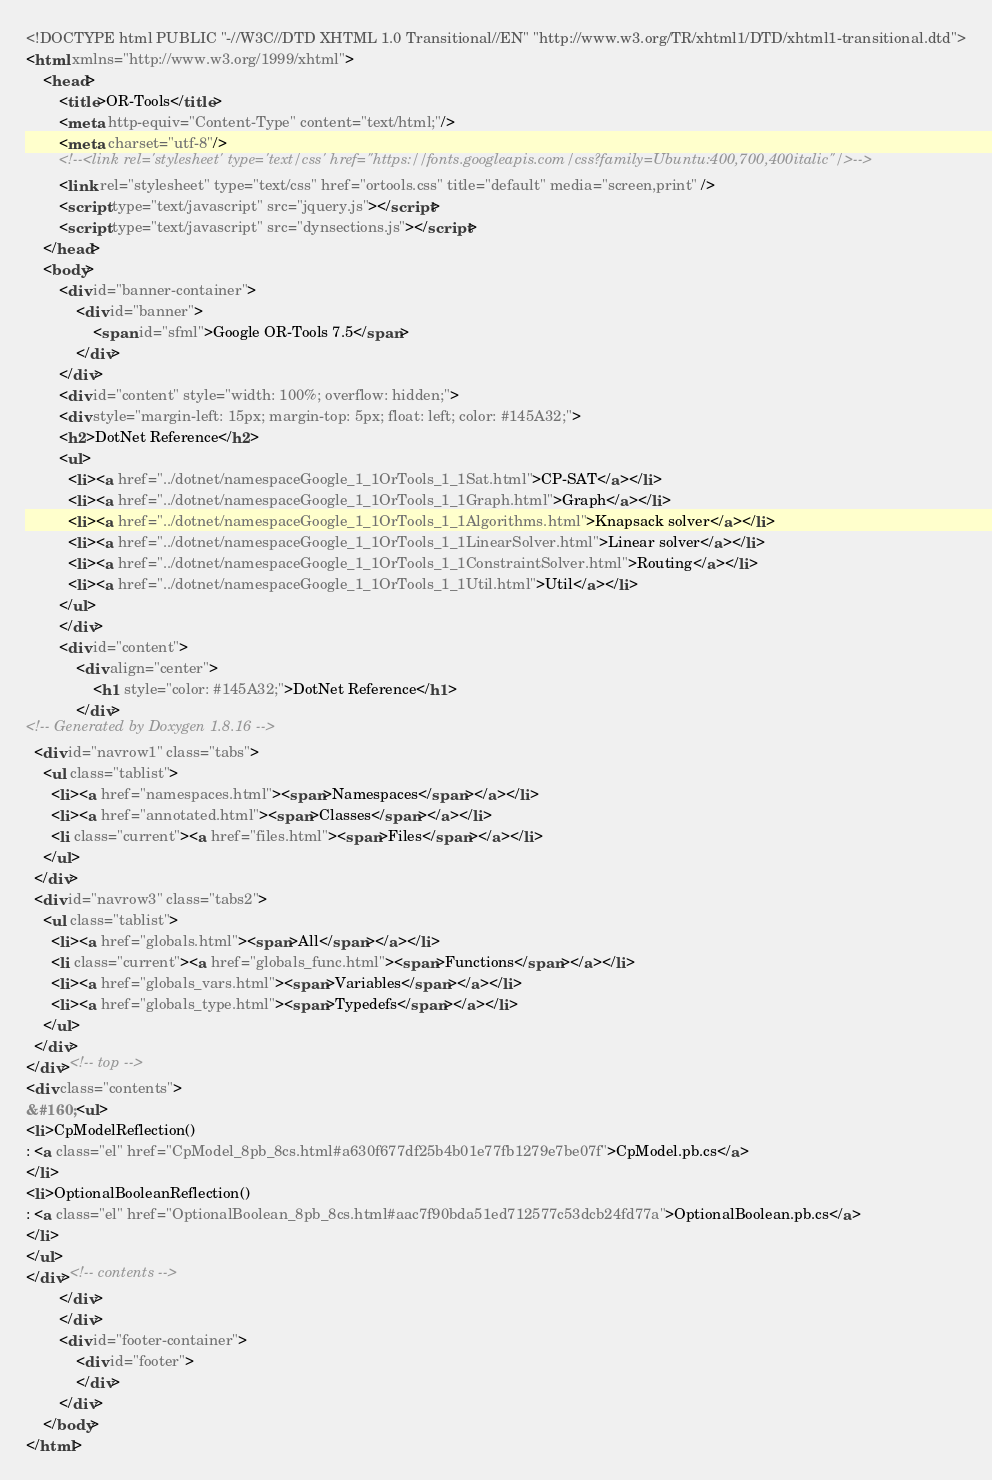Convert code to text. <code><loc_0><loc_0><loc_500><loc_500><_HTML_><!DOCTYPE html PUBLIC "-//W3C//DTD XHTML 1.0 Transitional//EN" "http://www.w3.org/TR/xhtml1/DTD/xhtml1-transitional.dtd">
<html xmlns="http://www.w3.org/1999/xhtml">
    <head>
        <title>OR-Tools</title>
        <meta http-equiv="Content-Type" content="text/html;"/>
        <meta charset="utf-8"/>
        <!--<link rel='stylesheet' type='text/css' href="https://fonts.googleapis.com/css?family=Ubuntu:400,700,400italic"/>-->
        <link rel="stylesheet" type="text/css" href="ortools.css" title="default" media="screen,print" />
        <script type="text/javascript" src="jquery.js"></script>
        <script type="text/javascript" src="dynsections.js"></script>
    </head>
    <body>
        <div id="banner-container">
            <div id="banner">
                <span id="sfml">Google OR-Tools 7.5</span>
            </div>
        </div>
        <div id="content" style="width: 100%; overflow: hidden;">
        <div style="margin-left: 15px; margin-top: 5px; float: left; color: #145A32;">
        <h2>DotNet Reference</h2>
        <ul>
          <li><a href="../dotnet/namespaceGoogle_1_1OrTools_1_1Sat.html">CP-SAT</a></li>
          <li><a href="../dotnet/namespaceGoogle_1_1OrTools_1_1Graph.html">Graph</a></li>
          <li><a href="../dotnet/namespaceGoogle_1_1OrTools_1_1Algorithms.html">Knapsack solver</a></li>
          <li><a href="../dotnet/namespaceGoogle_1_1OrTools_1_1LinearSolver.html">Linear solver</a></li>
          <li><a href="../dotnet/namespaceGoogle_1_1OrTools_1_1ConstraintSolver.html">Routing</a></li>
          <li><a href="../dotnet/namespaceGoogle_1_1OrTools_1_1Util.html">Util</a></li>
        </ul>
        </div>
        <div id="content">
            <div align="center">
                <h1 style="color: #145A32;">DotNet Reference</h1>
            </div>
<!-- Generated by Doxygen 1.8.16 -->
  <div id="navrow1" class="tabs">
    <ul class="tablist">
      <li><a href="namespaces.html"><span>Namespaces</span></a></li>
      <li><a href="annotated.html"><span>Classes</span></a></li>
      <li class="current"><a href="files.html"><span>Files</span></a></li>
    </ul>
  </div>
  <div id="navrow3" class="tabs2">
    <ul class="tablist">
      <li><a href="globals.html"><span>All</span></a></li>
      <li class="current"><a href="globals_func.html"><span>Functions</span></a></li>
      <li><a href="globals_vars.html"><span>Variables</span></a></li>
      <li><a href="globals_type.html"><span>Typedefs</span></a></li>
    </ul>
  </div>
</div><!-- top -->
<div class="contents">
&#160;<ul>
<li>CpModelReflection()
: <a class="el" href="CpModel_8pb_8cs.html#a630f677df25b4b01e77fb1279e7be07f">CpModel.pb.cs</a>
</li>
<li>OptionalBooleanReflection()
: <a class="el" href="OptionalBoolean_8pb_8cs.html#aac7f90bda51ed712577c53dcb24fd77a">OptionalBoolean.pb.cs</a>
</li>
</ul>
</div><!-- contents -->
        </div>
        </div>
        <div id="footer-container">
            <div id="footer">
            </div>
        </div>
    </body>
</html>
</code> 